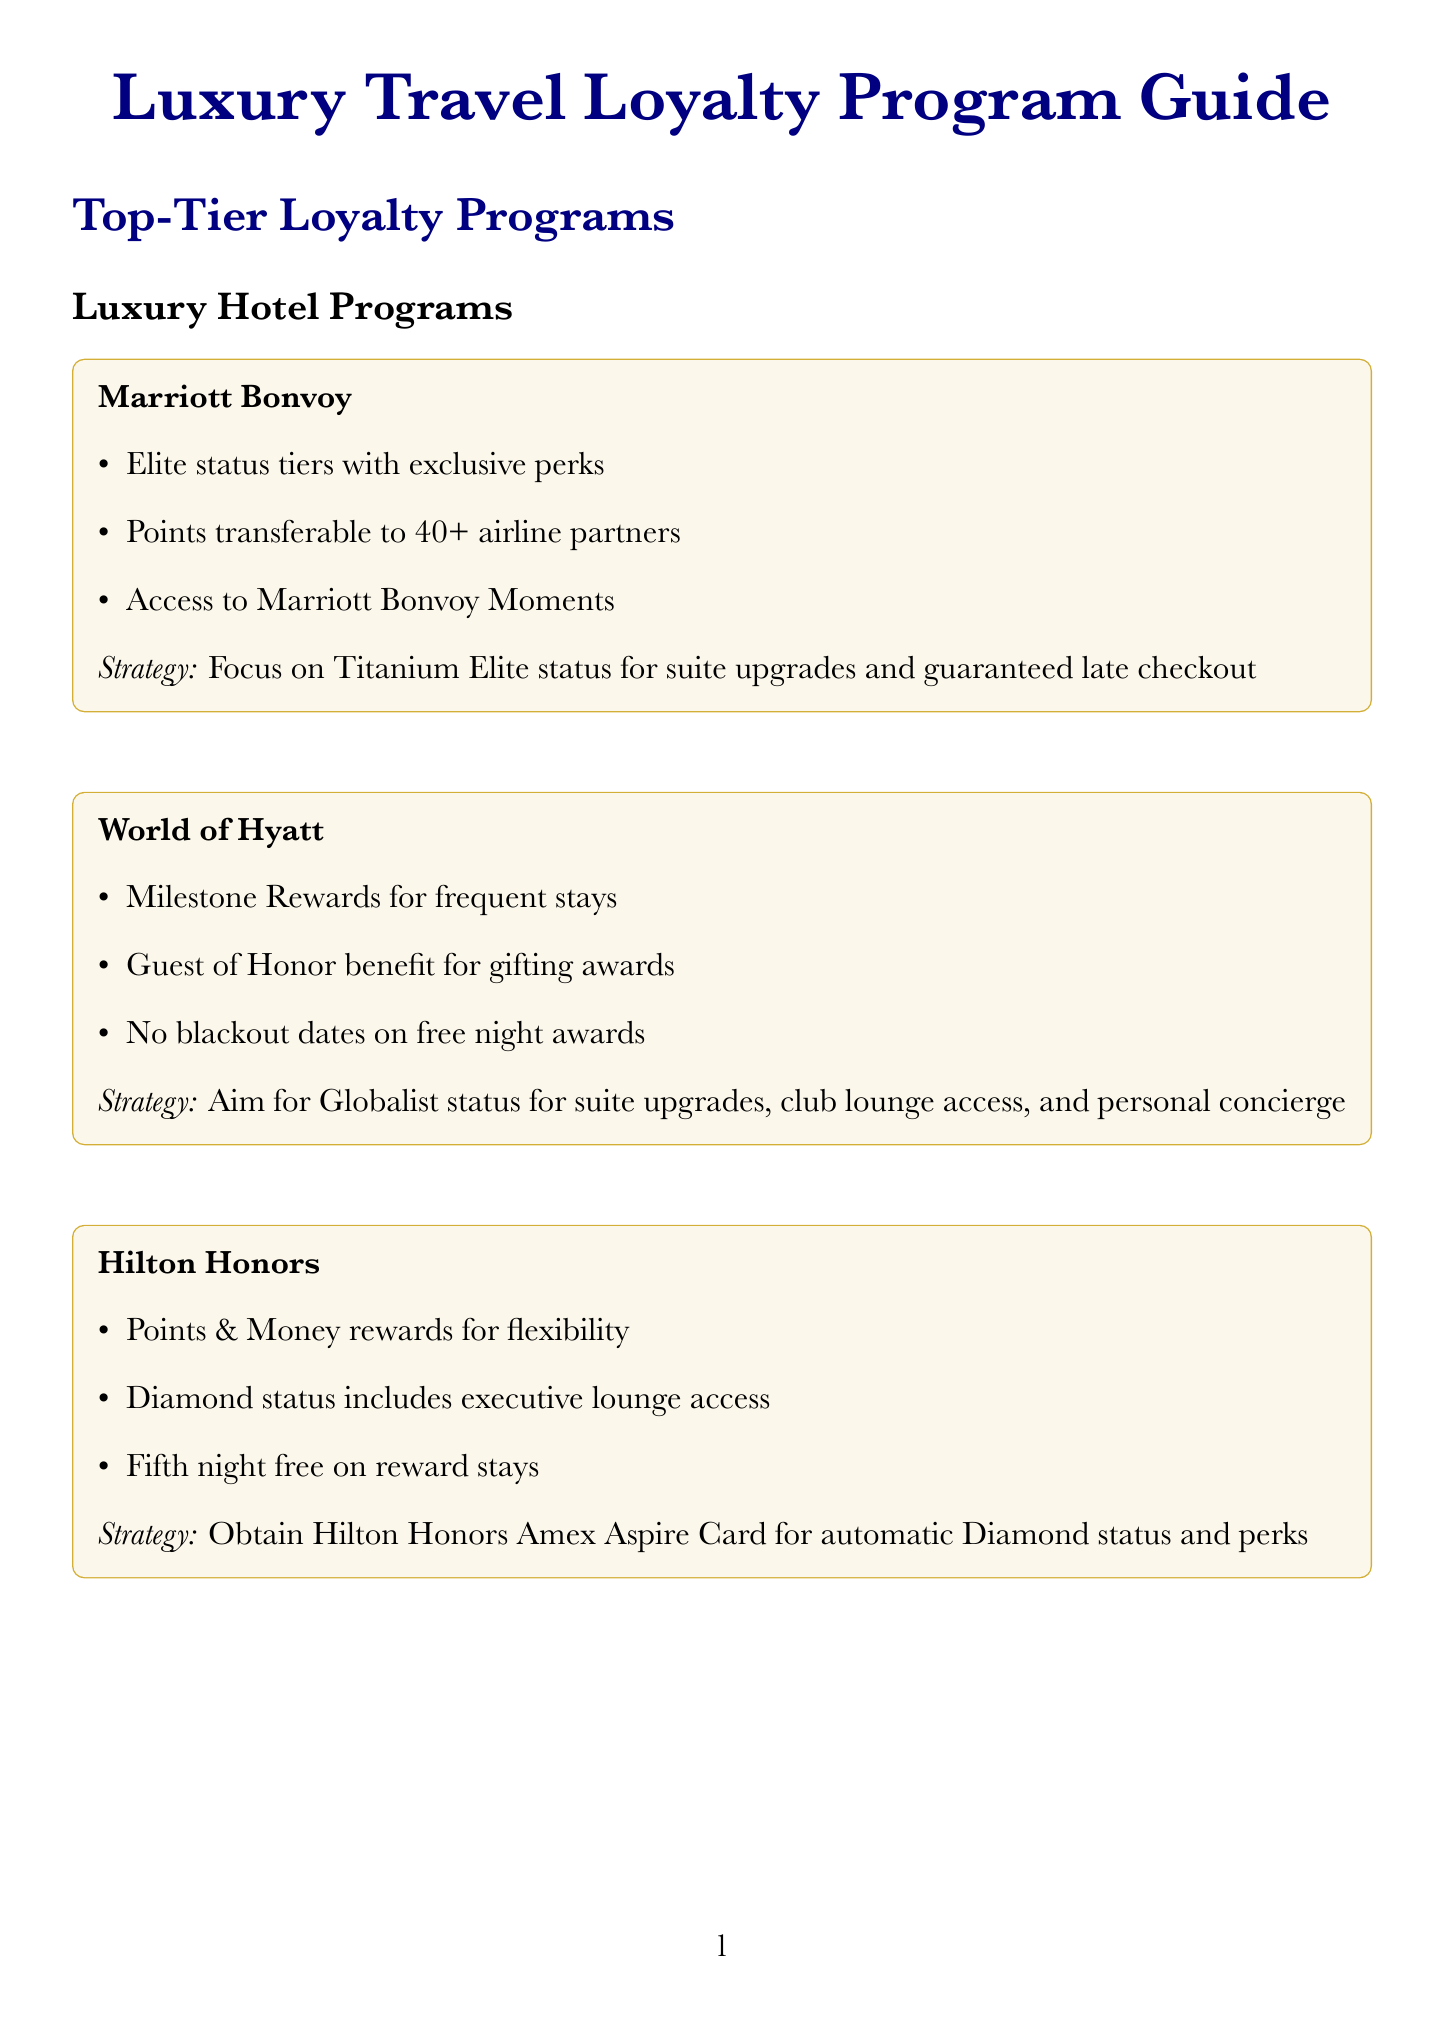What is a benefit of Marriott Bonvoy? The document lists several benefits of Marriott Bonvoy, including elite status tiers with exclusive perks.
Answer: Elite status tiers with exclusive perks What status should you aim for with Hilton Honors to get automatic benefits? The strategy section for Hilton Honors mentions obtaining the Hilton Honors American Express Aspire Card.
Answer: Automatic Diamond status What is a benefit of the Royal Caribbean Crown & Anchor Society? The document describes benefits such as priority check-in and boarding.
Answer: Priority check-in and boarding How can you leverage high-tier status in one program? The document discusses status matching as a strategy to obtain equivalent status.
Answer: Status matching What is a strategy to maximize Emirates Skywards benefits? Achieving Platinum status is mentioned as a recommended strategy for better benefits.
Answer: Achieve Platinum status Which loyalty program allows family pooling of miles? The document specifies that Emirates Skywards allows for family pooling of miles.
Answer: Emirates Skywards What exclusive experience does Hilton Honors offer? The document lists several exclusive experiences, including exclusive music festivals in exotic locations.
Answer: Exclusive music festivals in exotic locations What is a tip for wealthy travelers regarding accommodations? The document provides a customized travel tip about booking suites or premium cabins.
Answer: Book suites or premium cabins using points How many airline partners can Marriott Bonvoy points be transferred to? The document notes that points can be transferred to 40+ airline partners.
Answer: 40+ What is one way to achieve max travel benefits with multiple programs? The document mentions mixing and matching loyalty programs for benefits during trips.
Answer: Mixing and Matching 